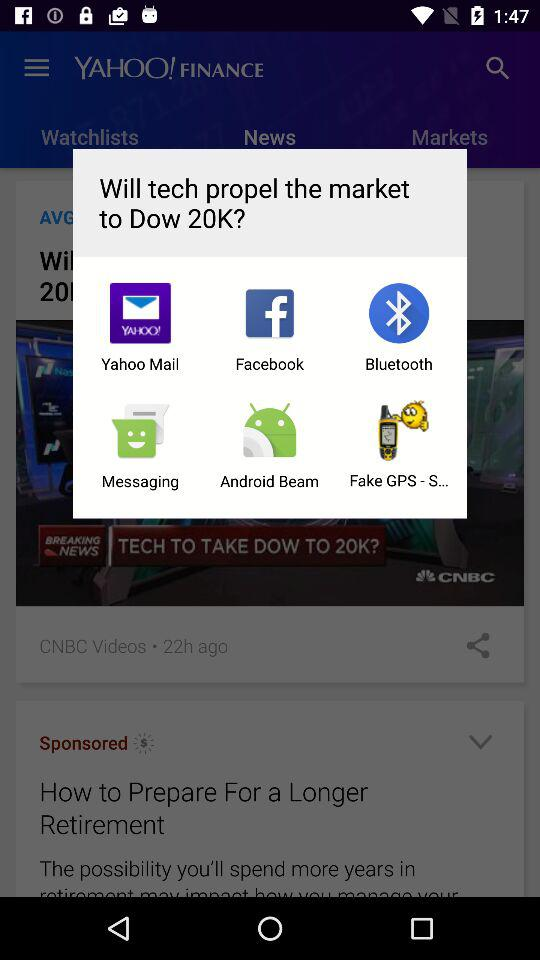What are the sharing options? The sharing options are "Yahoo Mail", "Facebook", "Bluetooth", "Messaging", "Android Beam" and "Fake GPS - S...". 